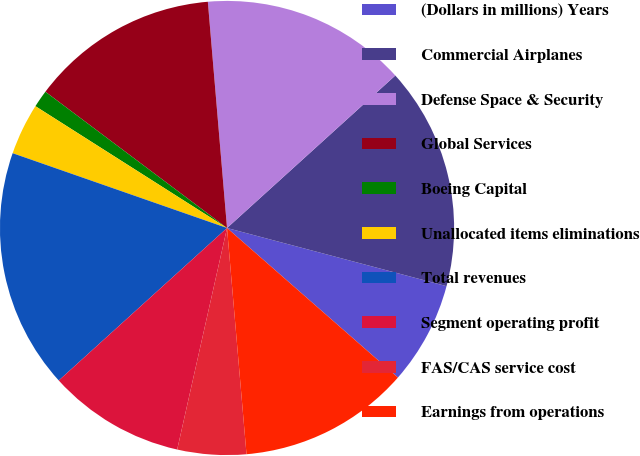Convert chart. <chart><loc_0><loc_0><loc_500><loc_500><pie_chart><fcel>(Dollars in millions) Years<fcel>Commercial Airplanes<fcel>Defense Space & Security<fcel>Global Services<fcel>Boeing Capital<fcel>Unallocated items eliminations<fcel>Total revenues<fcel>Segment operating profit<fcel>FAS/CAS service cost<fcel>Earnings from operations<nl><fcel>7.32%<fcel>15.84%<fcel>14.63%<fcel>13.41%<fcel>1.23%<fcel>3.67%<fcel>17.06%<fcel>9.76%<fcel>4.89%<fcel>12.19%<nl></chart> 